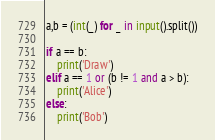<code> <loc_0><loc_0><loc_500><loc_500><_Python_>a,b = (int(_) for _ in input().split())

if a == b:
    print('Draw')
elif a == 1 or (b != 1 and a > b):
    print('Alice')
else:
    print('Bob')</code> 